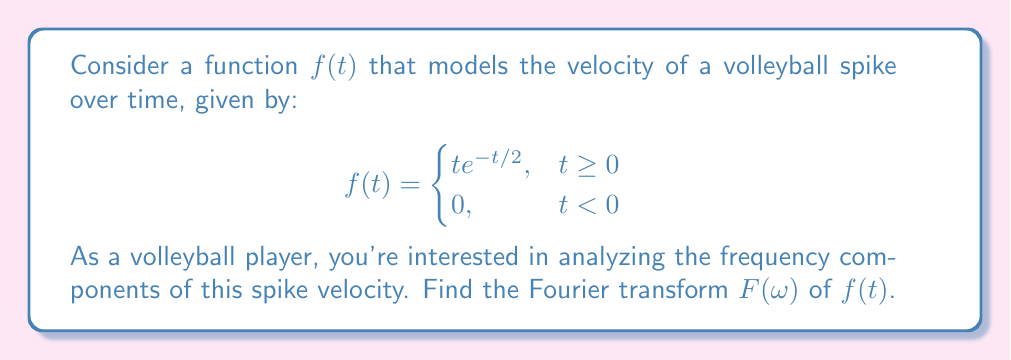Provide a solution to this math problem. Let's approach this step-by-step:

1) The Fourier transform is defined as:
   $$F(\omega) = \int_{-\infty}^{\infty} f(t)e^{-i\omega t}dt$$

2) Given that $f(t) = 0$ for $t < 0$, we can change the limits of integration:
   $$F(\omega) = \int_{0}^{\infty} te^{-t/2}e^{-i\omega t}dt$$

3) Let's simplify the integrand:
   $$F(\omega) = \int_{0}^{\infty} te^{-t(1/2 + i\omega)}dt$$

4) This integral can be solved using integration by parts. Let $u = t$ and $dv = e^{-t(1/2 + i\omega)}dt$. Then:
   $$du = dt$$
   $$v = -\frac{1}{1/2 + i\omega}e^{-t(1/2 + i\omega)}$$

5) Applying integration by parts:
   $$F(\omega) = \left[-\frac{t}{1/2 + i\omega}e^{-t(1/2 + i\omega)}\right]_{0}^{\infty} + \int_{0}^{\infty} \frac{1}{1/2 + i\omega}e^{-t(1/2 + i\omega)}dt$$

6) The first term evaluates to zero at both limits. For the second term:
   $$F(\omega) = \frac{1}{1/2 + i\omega} \int_{0}^{\infty} e^{-t(1/2 + i\omega)}dt$$

7) Evaluating this integral:
   $$F(\omega) = \frac{1}{1/2 + i\omega} \left[-\frac{1}{1/2 + i\omega}e^{-t(1/2 + i\omega)}\right]_{0}^{\infty}$$

8) Simplifying:
   $$F(\omega) = \frac{1}{(1/2 + i\omega)^2}$$

9) To express this in standard form, multiply numerator and denominator by the complex conjugate:
   $$F(\omega) = \frac{(1/2 - i\omega)^2}{((1/2)^2 + \omega^2)^2} = \frac{1/4 - \omega^2 - i\omega}{(1/4 + \omega^2)^2}$$
Answer: $F(\omega) = \frac{1/4 - \omega^2 - i\omega}{(1/4 + \omega^2)^2}$ 